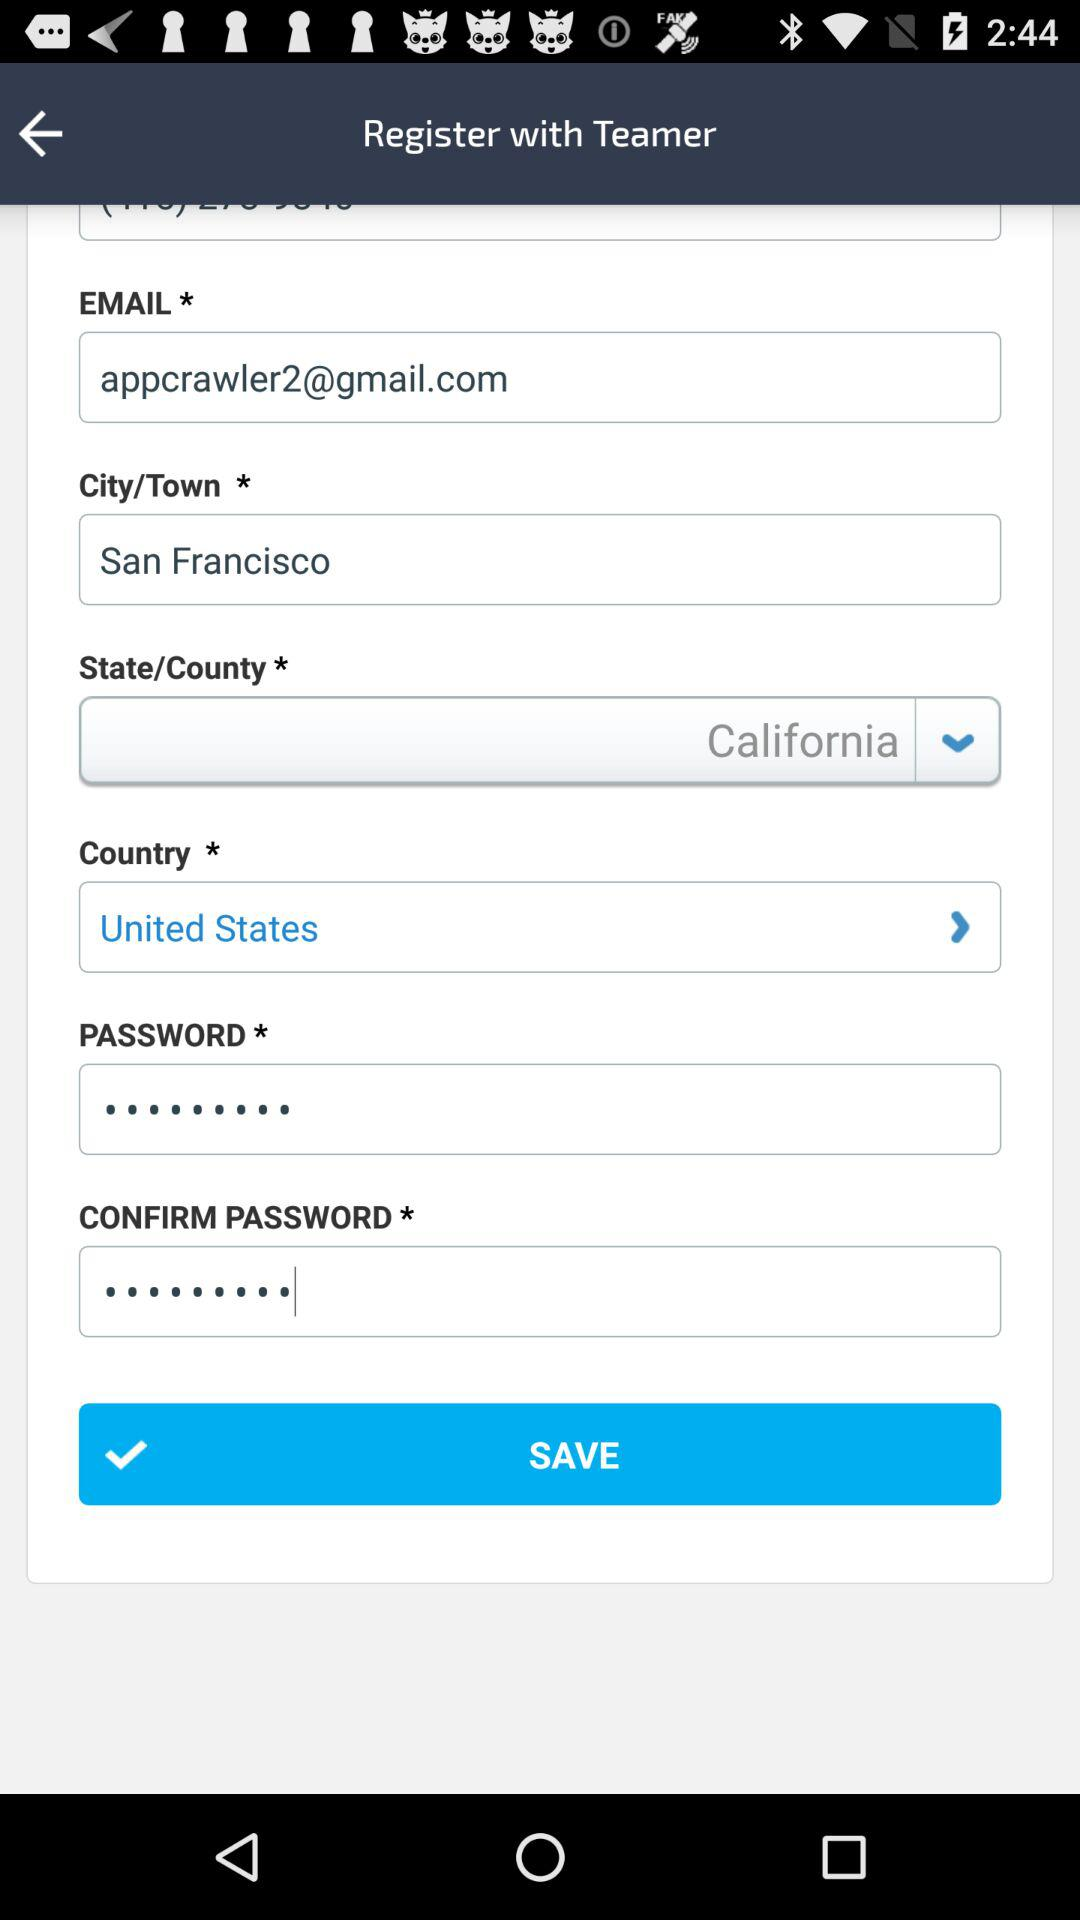Which is the selected country? The selected country is the United States. 